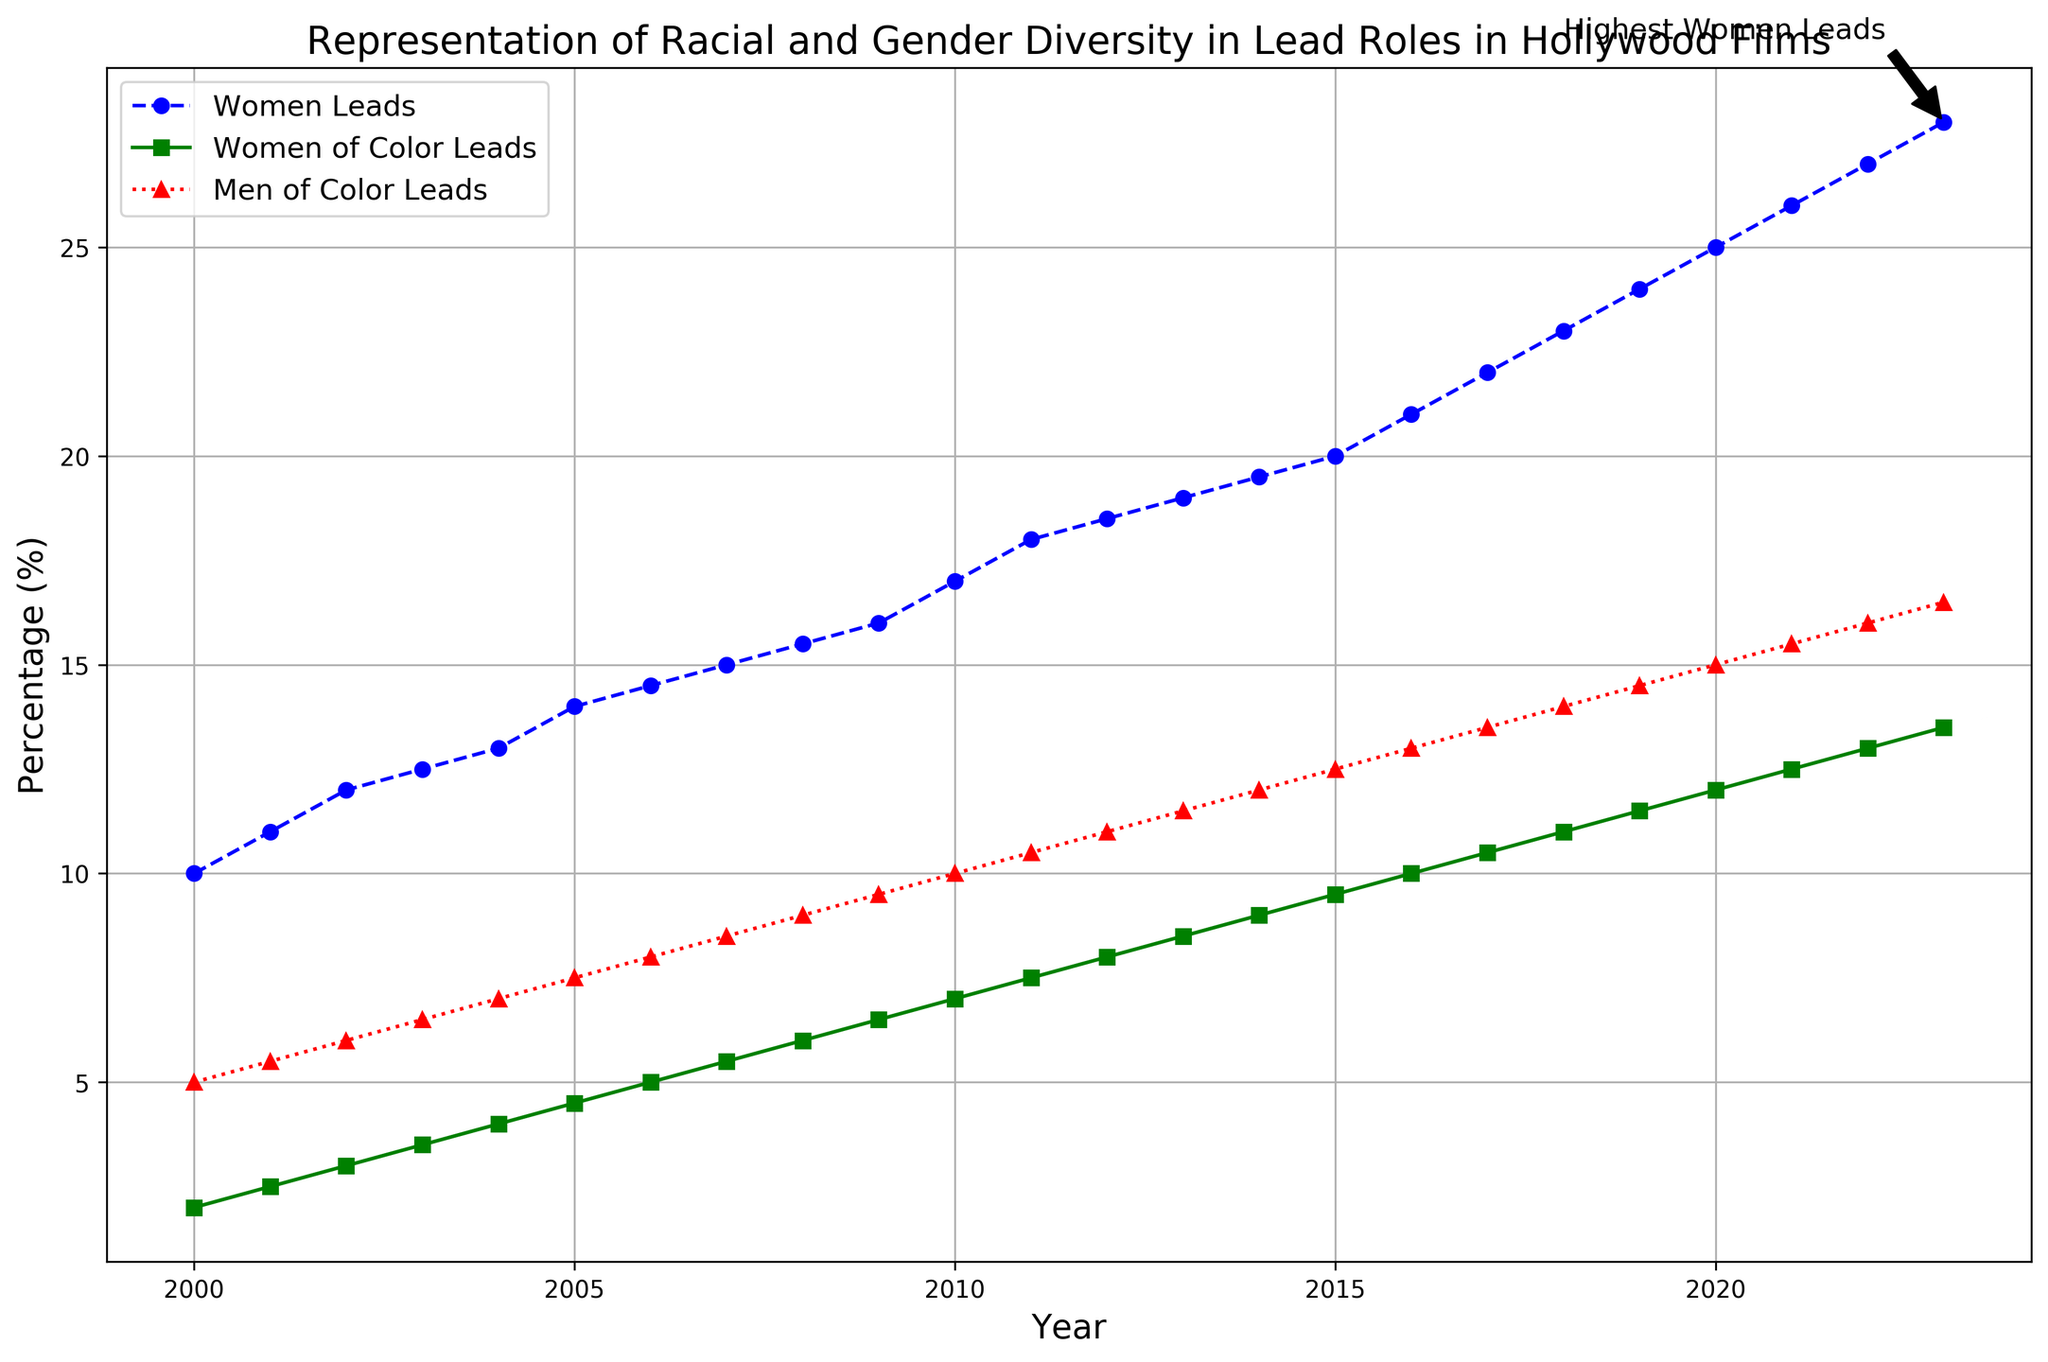What is the percentage of women leads in 2023? Look at the 'Women Leads' line for the year 2023. The percentage is marked near the end of the line.
Answer: 28 Which year has the highest representation of women leads? Observe the blue line labeled 'Women Leads' and find the highest point on the graph. The highest point corresponds to the year 2023.
Answer: 2023 How does the representation of women of color leads change between 2000 and 2023? Compare the green line at the year 2000 and 2023. In 2000, the percentage starts at 2, and in 2023, it reaches 13.5.
Answer: Increased by 11.5 What is the difference in the percentage of men of color leads between 2020 and 2023? Check the red line values at 2020 and 2023. The percentage is 15 in 2020 and 16.5 in 2023. The difference is 16.5 - 15.
Answer: 1.5 Which group had the lowest representation in 2000? Look at the beginning of the three lines in the year 2000. The 'Women of Color Leads' (green line) has the lowest percentage (2).
Answer: Women of Color Leads By how much did the percentage of women leads increase from 2000 to 2023? Find the value on the blue line in 2000 and 2023. Calculate the difference: 28 (2023) - 10 (2000).
Answer: 18 Which color line represents the women leads data? Look at the legend and match the color with the label 'Women Leads'. It is blue.
Answer: Blue In which year did the percentage of men of color leads first surpass 10%? Follow the red line and look for the first point where it crosses the 10% mark. This occurs between 2011 and 2012.
Answer: 2011 What is the percentage of women of color leads in 2015? Find the year 2015 on the x-axis and trace it up to the green line marked by squares. The percentage is 9.5.
Answer: 9.5 Compare the trend of women leads to men of color leads from 2000 to 2023. Both the blue and red lines show an increasing trend. The women leads line starts at 10% and ends at 28%, while the men of color leads line starts at 5% and ends at 16.5%.
Answer: Both increased 